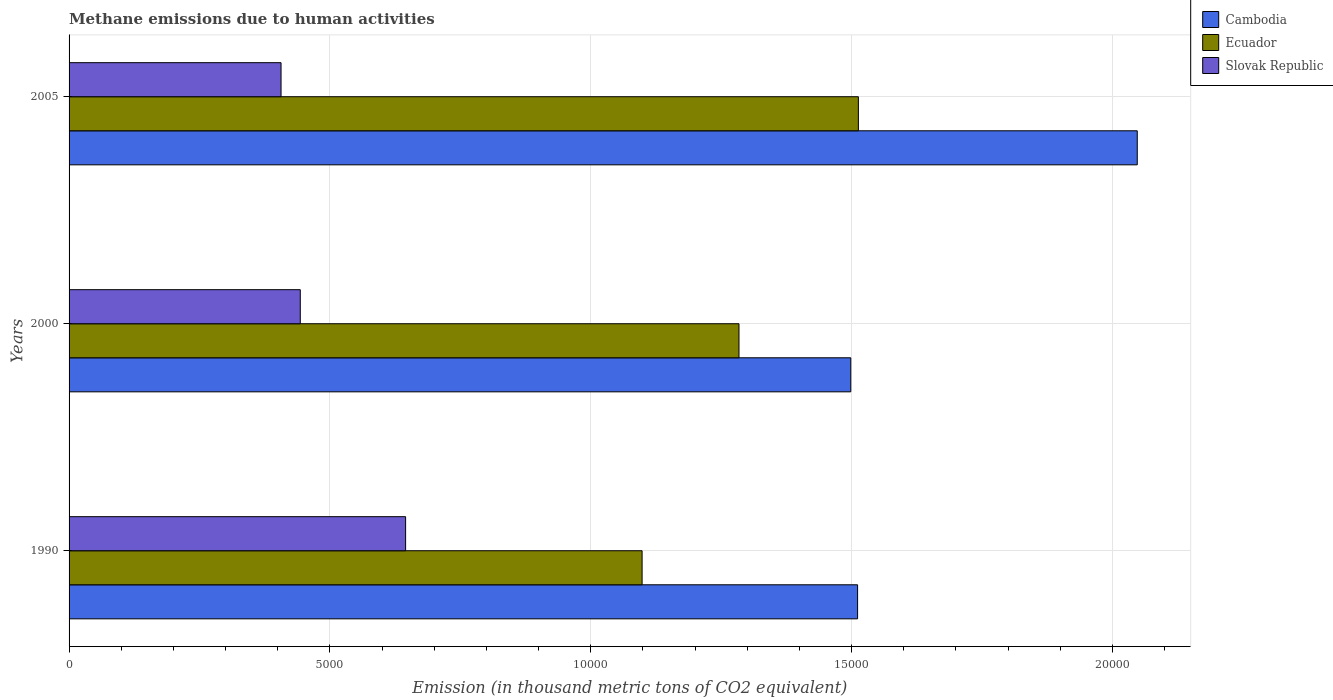Are the number of bars per tick equal to the number of legend labels?
Give a very brief answer. Yes. Are the number of bars on each tick of the Y-axis equal?
Your answer should be very brief. Yes. How many bars are there on the 2nd tick from the top?
Offer a terse response. 3. What is the label of the 1st group of bars from the top?
Your response must be concise. 2005. What is the amount of methane emitted in Cambodia in 1990?
Provide a short and direct response. 1.51e+04. Across all years, what is the maximum amount of methane emitted in Cambodia?
Your answer should be compact. 2.05e+04. Across all years, what is the minimum amount of methane emitted in Slovak Republic?
Offer a very short reply. 4063.5. In which year was the amount of methane emitted in Slovak Republic maximum?
Offer a very short reply. 1990. What is the total amount of methane emitted in Ecuador in the graph?
Offer a terse response. 3.90e+04. What is the difference between the amount of methane emitted in Ecuador in 1990 and that in 2000?
Your response must be concise. -1857.4. What is the difference between the amount of methane emitted in Slovak Republic in 1990 and the amount of methane emitted in Cambodia in 2000?
Provide a succinct answer. -8533.5. What is the average amount of methane emitted in Slovak Republic per year?
Provide a short and direct response. 4982.4. In the year 2000, what is the difference between the amount of methane emitted in Slovak Republic and amount of methane emitted in Cambodia?
Keep it short and to the point. -1.06e+04. In how many years, is the amount of methane emitted in Slovak Republic greater than 7000 thousand metric tons?
Offer a very short reply. 0. What is the ratio of the amount of methane emitted in Slovak Republic in 2000 to that in 2005?
Make the answer very short. 1.09. Is the amount of methane emitted in Ecuador in 1990 less than that in 2005?
Your answer should be compact. Yes. What is the difference between the highest and the second highest amount of methane emitted in Cambodia?
Your answer should be compact. 5361.1. What is the difference between the highest and the lowest amount of methane emitted in Cambodia?
Offer a terse response. 5491.9. Is the sum of the amount of methane emitted in Ecuador in 2000 and 2005 greater than the maximum amount of methane emitted in Cambodia across all years?
Your answer should be compact. Yes. What does the 3rd bar from the top in 2000 represents?
Your answer should be compact. Cambodia. What does the 1st bar from the bottom in 2005 represents?
Your answer should be compact. Cambodia. How many bars are there?
Offer a very short reply. 9. How many years are there in the graph?
Provide a short and direct response. 3. Does the graph contain any zero values?
Provide a short and direct response. No. Does the graph contain grids?
Give a very brief answer. Yes. Where does the legend appear in the graph?
Ensure brevity in your answer.  Top right. How many legend labels are there?
Your answer should be compact. 3. What is the title of the graph?
Give a very brief answer. Methane emissions due to human activities. What is the label or title of the X-axis?
Your answer should be compact. Emission (in thousand metric tons of CO2 equivalent). What is the label or title of the Y-axis?
Make the answer very short. Years. What is the Emission (in thousand metric tons of CO2 equivalent) in Cambodia in 1990?
Provide a succinct answer. 1.51e+04. What is the Emission (in thousand metric tons of CO2 equivalent) of Ecuador in 1990?
Make the answer very short. 1.10e+04. What is the Emission (in thousand metric tons of CO2 equivalent) in Slovak Republic in 1990?
Offer a terse response. 6451.4. What is the Emission (in thousand metric tons of CO2 equivalent) in Cambodia in 2000?
Your response must be concise. 1.50e+04. What is the Emission (in thousand metric tons of CO2 equivalent) of Ecuador in 2000?
Provide a short and direct response. 1.28e+04. What is the Emission (in thousand metric tons of CO2 equivalent) in Slovak Republic in 2000?
Offer a very short reply. 4432.3. What is the Emission (in thousand metric tons of CO2 equivalent) in Cambodia in 2005?
Make the answer very short. 2.05e+04. What is the Emission (in thousand metric tons of CO2 equivalent) of Ecuador in 2005?
Offer a very short reply. 1.51e+04. What is the Emission (in thousand metric tons of CO2 equivalent) in Slovak Republic in 2005?
Offer a very short reply. 4063.5. Across all years, what is the maximum Emission (in thousand metric tons of CO2 equivalent) of Cambodia?
Provide a succinct answer. 2.05e+04. Across all years, what is the maximum Emission (in thousand metric tons of CO2 equivalent) in Ecuador?
Offer a terse response. 1.51e+04. Across all years, what is the maximum Emission (in thousand metric tons of CO2 equivalent) of Slovak Republic?
Provide a short and direct response. 6451.4. Across all years, what is the minimum Emission (in thousand metric tons of CO2 equivalent) of Cambodia?
Give a very brief answer. 1.50e+04. Across all years, what is the minimum Emission (in thousand metric tons of CO2 equivalent) of Ecuador?
Provide a succinct answer. 1.10e+04. Across all years, what is the minimum Emission (in thousand metric tons of CO2 equivalent) in Slovak Republic?
Give a very brief answer. 4063.5. What is the total Emission (in thousand metric tons of CO2 equivalent) in Cambodia in the graph?
Provide a short and direct response. 5.06e+04. What is the total Emission (in thousand metric tons of CO2 equivalent) of Ecuador in the graph?
Your answer should be very brief. 3.90e+04. What is the total Emission (in thousand metric tons of CO2 equivalent) of Slovak Republic in the graph?
Offer a very short reply. 1.49e+04. What is the difference between the Emission (in thousand metric tons of CO2 equivalent) of Cambodia in 1990 and that in 2000?
Keep it short and to the point. 130.8. What is the difference between the Emission (in thousand metric tons of CO2 equivalent) in Ecuador in 1990 and that in 2000?
Provide a short and direct response. -1857.4. What is the difference between the Emission (in thousand metric tons of CO2 equivalent) in Slovak Republic in 1990 and that in 2000?
Ensure brevity in your answer.  2019.1. What is the difference between the Emission (in thousand metric tons of CO2 equivalent) in Cambodia in 1990 and that in 2005?
Provide a succinct answer. -5361.1. What is the difference between the Emission (in thousand metric tons of CO2 equivalent) of Ecuador in 1990 and that in 2005?
Keep it short and to the point. -4145.9. What is the difference between the Emission (in thousand metric tons of CO2 equivalent) in Slovak Republic in 1990 and that in 2005?
Provide a short and direct response. 2387.9. What is the difference between the Emission (in thousand metric tons of CO2 equivalent) in Cambodia in 2000 and that in 2005?
Your response must be concise. -5491.9. What is the difference between the Emission (in thousand metric tons of CO2 equivalent) in Ecuador in 2000 and that in 2005?
Your answer should be compact. -2288.5. What is the difference between the Emission (in thousand metric tons of CO2 equivalent) of Slovak Republic in 2000 and that in 2005?
Ensure brevity in your answer.  368.8. What is the difference between the Emission (in thousand metric tons of CO2 equivalent) in Cambodia in 1990 and the Emission (in thousand metric tons of CO2 equivalent) in Ecuador in 2000?
Make the answer very short. 2273.7. What is the difference between the Emission (in thousand metric tons of CO2 equivalent) of Cambodia in 1990 and the Emission (in thousand metric tons of CO2 equivalent) of Slovak Republic in 2000?
Offer a very short reply. 1.07e+04. What is the difference between the Emission (in thousand metric tons of CO2 equivalent) in Ecuador in 1990 and the Emission (in thousand metric tons of CO2 equivalent) in Slovak Republic in 2000?
Ensure brevity in your answer.  6552.3. What is the difference between the Emission (in thousand metric tons of CO2 equivalent) in Cambodia in 1990 and the Emission (in thousand metric tons of CO2 equivalent) in Ecuador in 2005?
Provide a succinct answer. -14.8. What is the difference between the Emission (in thousand metric tons of CO2 equivalent) of Cambodia in 1990 and the Emission (in thousand metric tons of CO2 equivalent) of Slovak Republic in 2005?
Offer a very short reply. 1.11e+04. What is the difference between the Emission (in thousand metric tons of CO2 equivalent) in Ecuador in 1990 and the Emission (in thousand metric tons of CO2 equivalent) in Slovak Republic in 2005?
Keep it short and to the point. 6921.1. What is the difference between the Emission (in thousand metric tons of CO2 equivalent) in Cambodia in 2000 and the Emission (in thousand metric tons of CO2 equivalent) in Ecuador in 2005?
Your answer should be very brief. -145.6. What is the difference between the Emission (in thousand metric tons of CO2 equivalent) of Cambodia in 2000 and the Emission (in thousand metric tons of CO2 equivalent) of Slovak Republic in 2005?
Offer a terse response. 1.09e+04. What is the difference between the Emission (in thousand metric tons of CO2 equivalent) in Ecuador in 2000 and the Emission (in thousand metric tons of CO2 equivalent) in Slovak Republic in 2005?
Your response must be concise. 8778.5. What is the average Emission (in thousand metric tons of CO2 equivalent) of Cambodia per year?
Offer a terse response. 1.69e+04. What is the average Emission (in thousand metric tons of CO2 equivalent) of Ecuador per year?
Make the answer very short. 1.30e+04. What is the average Emission (in thousand metric tons of CO2 equivalent) of Slovak Republic per year?
Give a very brief answer. 4982.4. In the year 1990, what is the difference between the Emission (in thousand metric tons of CO2 equivalent) in Cambodia and Emission (in thousand metric tons of CO2 equivalent) in Ecuador?
Ensure brevity in your answer.  4131.1. In the year 1990, what is the difference between the Emission (in thousand metric tons of CO2 equivalent) in Cambodia and Emission (in thousand metric tons of CO2 equivalent) in Slovak Republic?
Provide a succinct answer. 8664.3. In the year 1990, what is the difference between the Emission (in thousand metric tons of CO2 equivalent) in Ecuador and Emission (in thousand metric tons of CO2 equivalent) in Slovak Republic?
Offer a very short reply. 4533.2. In the year 2000, what is the difference between the Emission (in thousand metric tons of CO2 equivalent) of Cambodia and Emission (in thousand metric tons of CO2 equivalent) of Ecuador?
Provide a short and direct response. 2142.9. In the year 2000, what is the difference between the Emission (in thousand metric tons of CO2 equivalent) in Cambodia and Emission (in thousand metric tons of CO2 equivalent) in Slovak Republic?
Provide a succinct answer. 1.06e+04. In the year 2000, what is the difference between the Emission (in thousand metric tons of CO2 equivalent) in Ecuador and Emission (in thousand metric tons of CO2 equivalent) in Slovak Republic?
Your answer should be very brief. 8409.7. In the year 2005, what is the difference between the Emission (in thousand metric tons of CO2 equivalent) in Cambodia and Emission (in thousand metric tons of CO2 equivalent) in Ecuador?
Offer a very short reply. 5346.3. In the year 2005, what is the difference between the Emission (in thousand metric tons of CO2 equivalent) in Cambodia and Emission (in thousand metric tons of CO2 equivalent) in Slovak Republic?
Provide a succinct answer. 1.64e+04. In the year 2005, what is the difference between the Emission (in thousand metric tons of CO2 equivalent) of Ecuador and Emission (in thousand metric tons of CO2 equivalent) of Slovak Republic?
Your response must be concise. 1.11e+04. What is the ratio of the Emission (in thousand metric tons of CO2 equivalent) in Cambodia in 1990 to that in 2000?
Ensure brevity in your answer.  1.01. What is the ratio of the Emission (in thousand metric tons of CO2 equivalent) of Ecuador in 1990 to that in 2000?
Offer a very short reply. 0.86. What is the ratio of the Emission (in thousand metric tons of CO2 equivalent) in Slovak Republic in 1990 to that in 2000?
Your response must be concise. 1.46. What is the ratio of the Emission (in thousand metric tons of CO2 equivalent) of Cambodia in 1990 to that in 2005?
Ensure brevity in your answer.  0.74. What is the ratio of the Emission (in thousand metric tons of CO2 equivalent) in Ecuador in 1990 to that in 2005?
Offer a terse response. 0.73. What is the ratio of the Emission (in thousand metric tons of CO2 equivalent) of Slovak Republic in 1990 to that in 2005?
Offer a very short reply. 1.59. What is the ratio of the Emission (in thousand metric tons of CO2 equivalent) of Cambodia in 2000 to that in 2005?
Offer a terse response. 0.73. What is the ratio of the Emission (in thousand metric tons of CO2 equivalent) in Ecuador in 2000 to that in 2005?
Make the answer very short. 0.85. What is the ratio of the Emission (in thousand metric tons of CO2 equivalent) of Slovak Republic in 2000 to that in 2005?
Give a very brief answer. 1.09. What is the difference between the highest and the second highest Emission (in thousand metric tons of CO2 equivalent) in Cambodia?
Provide a short and direct response. 5361.1. What is the difference between the highest and the second highest Emission (in thousand metric tons of CO2 equivalent) in Ecuador?
Provide a short and direct response. 2288.5. What is the difference between the highest and the second highest Emission (in thousand metric tons of CO2 equivalent) in Slovak Republic?
Give a very brief answer. 2019.1. What is the difference between the highest and the lowest Emission (in thousand metric tons of CO2 equivalent) in Cambodia?
Provide a succinct answer. 5491.9. What is the difference between the highest and the lowest Emission (in thousand metric tons of CO2 equivalent) in Ecuador?
Your response must be concise. 4145.9. What is the difference between the highest and the lowest Emission (in thousand metric tons of CO2 equivalent) of Slovak Republic?
Keep it short and to the point. 2387.9. 